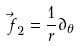Convert formula to latex. <formula><loc_0><loc_0><loc_500><loc_500>\vec { f } _ { 2 } = \frac { 1 } { r } \partial _ { \theta }</formula> 